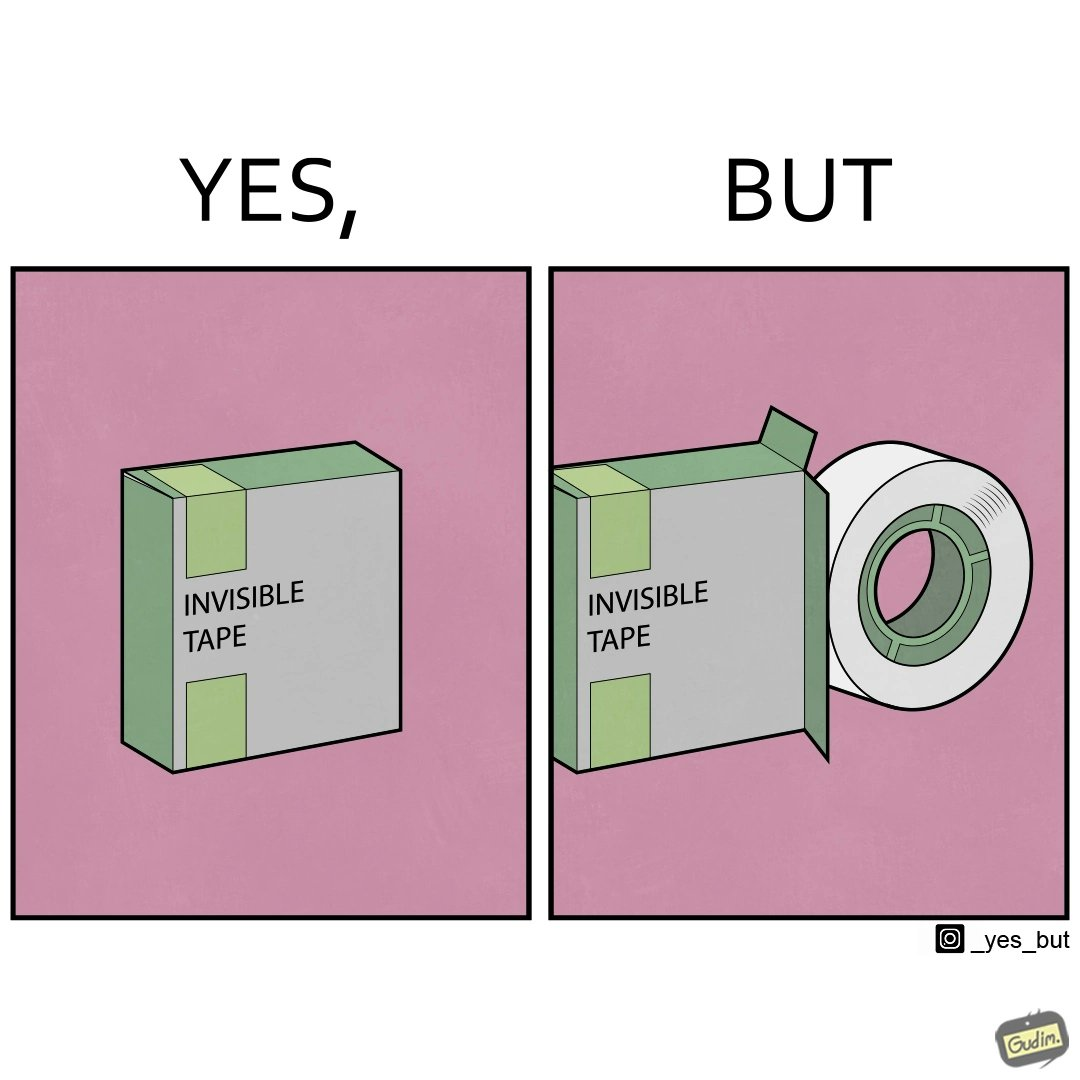What makes this image funny or satirical? The image is ironic, as the text on the pack reads 'invisible tape', but the tape inside it is actually visible. 